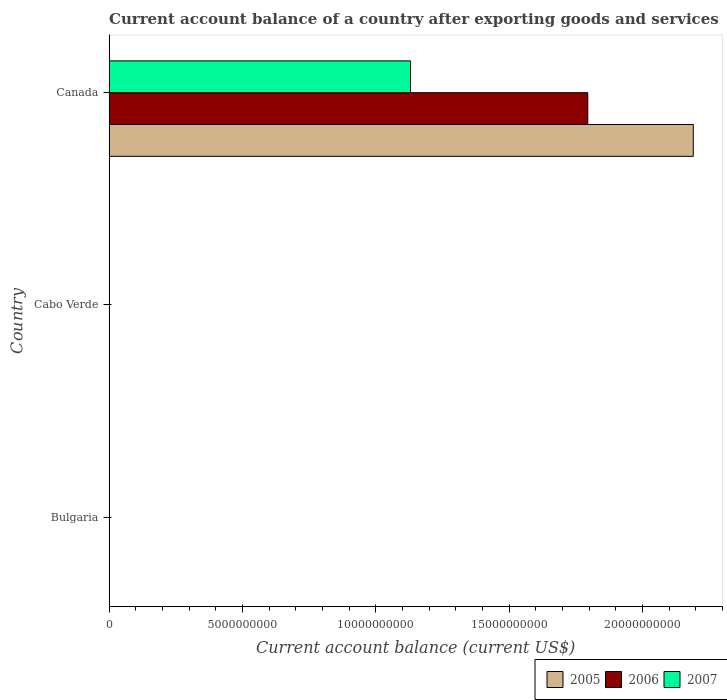How many different coloured bars are there?
Make the answer very short. 3. Are the number of bars per tick equal to the number of legend labels?
Your response must be concise. No. How many bars are there on the 3rd tick from the top?
Keep it short and to the point. 0. What is the label of the 2nd group of bars from the top?
Offer a terse response. Cabo Verde. In how many cases, is the number of bars for a given country not equal to the number of legend labels?
Ensure brevity in your answer.  2. What is the account balance in 2007 in Canada?
Ensure brevity in your answer.  1.13e+1. Across all countries, what is the maximum account balance in 2006?
Provide a succinct answer. 1.80e+1. In which country was the account balance in 2006 maximum?
Provide a succinct answer. Canada. What is the total account balance in 2007 in the graph?
Make the answer very short. 1.13e+1. What is the difference between the account balance in 2007 in Canada and the account balance in 2006 in Cabo Verde?
Give a very brief answer. 1.13e+1. What is the average account balance in 2007 per country?
Your answer should be very brief. 3.77e+09. What is the difference between the account balance in 2007 and account balance in 2005 in Canada?
Provide a short and direct response. -1.06e+1. In how many countries, is the account balance in 2005 greater than 22000000000 US$?
Provide a succinct answer. 0. What is the difference between the highest and the lowest account balance in 2006?
Keep it short and to the point. 1.80e+1. In how many countries, is the account balance in 2006 greater than the average account balance in 2006 taken over all countries?
Make the answer very short. 1. Is it the case that in every country, the sum of the account balance in 2006 and account balance in 2005 is greater than the account balance in 2007?
Your answer should be very brief. No. How many bars are there?
Give a very brief answer. 3. Are all the bars in the graph horizontal?
Keep it short and to the point. Yes. Are the values on the major ticks of X-axis written in scientific E-notation?
Make the answer very short. No. Does the graph contain any zero values?
Your answer should be compact. Yes. How are the legend labels stacked?
Ensure brevity in your answer.  Horizontal. What is the title of the graph?
Provide a short and direct response. Current account balance of a country after exporting goods and services. Does "1986" appear as one of the legend labels in the graph?
Your answer should be compact. No. What is the label or title of the X-axis?
Provide a succinct answer. Current account balance (current US$). What is the Current account balance (current US$) of 2005 in Bulgaria?
Give a very brief answer. 0. What is the Current account balance (current US$) in 2005 in Cabo Verde?
Provide a short and direct response. 0. What is the Current account balance (current US$) in 2006 in Cabo Verde?
Give a very brief answer. 0. What is the Current account balance (current US$) of 2005 in Canada?
Offer a terse response. 2.19e+1. What is the Current account balance (current US$) in 2006 in Canada?
Provide a succinct answer. 1.80e+1. What is the Current account balance (current US$) in 2007 in Canada?
Provide a succinct answer. 1.13e+1. Across all countries, what is the maximum Current account balance (current US$) of 2005?
Offer a very short reply. 2.19e+1. Across all countries, what is the maximum Current account balance (current US$) in 2006?
Ensure brevity in your answer.  1.80e+1. Across all countries, what is the maximum Current account balance (current US$) in 2007?
Keep it short and to the point. 1.13e+1. Across all countries, what is the minimum Current account balance (current US$) of 2007?
Provide a short and direct response. 0. What is the total Current account balance (current US$) in 2005 in the graph?
Your answer should be very brief. 2.19e+1. What is the total Current account balance (current US$) of 2006 in the graph?
Offer a very short reply. 1.80e+1. What is the total Current account balance (current US$) in 2007 in the graph?
Make the answer very short. 1.13e+1. What is the average Current account balance (current US$) in 2005 per country?
Keep it short and to the point. 7.30e+09. What is the average Current account balance (current US$) of 2006 per country?
Give a very brief answer. 5.98e+09. What is the average Current account balance (current US$) in 2007 per country?
Your answer should be compact. 3.77e+09. What is the difference between the Current account balance (current US$) in 2005 and Current account balance (current US$) in 2006 in Canada?
Give a very brief answer. 3.96e+09. What is the difference between the Current account balance (current US$) in 2005 and Current account balance (current US$) in 2007 in Canada?
Ensure brevity in your answer.  1.06e+1. What is the difference between the Current account balance (current US$) of 2006 and Current account balance (current US$) of 2007 in Canada?
Your answer should be very brief. 6.65e+09. What is the difference between the highest and the lowest Current account balance (current US$) of 2005?
Offer a terse response. 2.19e+1. What is the difference between the highest and the lowest Current account balance (current US$) in 2006?
Your response must be concise. 1.80e+1. What is the difference between the highest and the lowest Current account balance (current US$) in 2007?
Offer a terse response. 1.13e+1. 